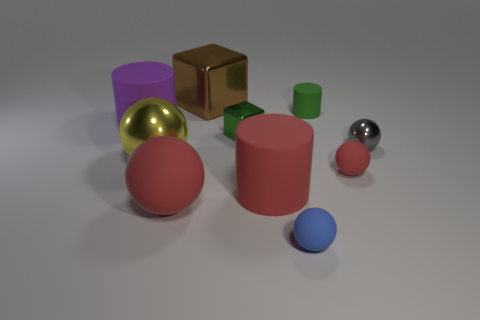Are there any red balls that are on the right side of the rubber ball to the left of the tiny matte sphere in front of the small red thing?
Ensure brevity in your answer.  Yes. Is the number of gray balls behind the brown metal cube less than the number of big purple rubber things?
Provide a short and direct response. Yes. What number of other objects are the same shape as the blue rubber object?
Ensure brevity in your answer.  4. How many objects are shiny balls that are on the right side of the blue matte thing or tiny balls to the left of the small metal sphere?
Your answer should be compact. 3. How big is the matte thing that is right of the red matte cylinder and behind the big yellow object?
Ensure brevity in your answer.  Small. There is a big red thing that is to the right of the small cube; is it the same shape as the purple object?
Your answer should be very brief. Yes. There is a cube that is behind the big cylinder behind the tiny metal thing that is left of the large red matte cylinder; what size is it?
Ensure brevity in your answer.  Large. What size is the cylinder that is the same color as the big rubber sphere?
Make the answer very short. Large. What number of objects are small cyan things or gray shiny balls?
Give a very brief answer. 1. What shape is the matte thing that is on the left side of the green shiny thing and to the right of the purple matte cylinder?
Your answer should be very brief. Sphere. 